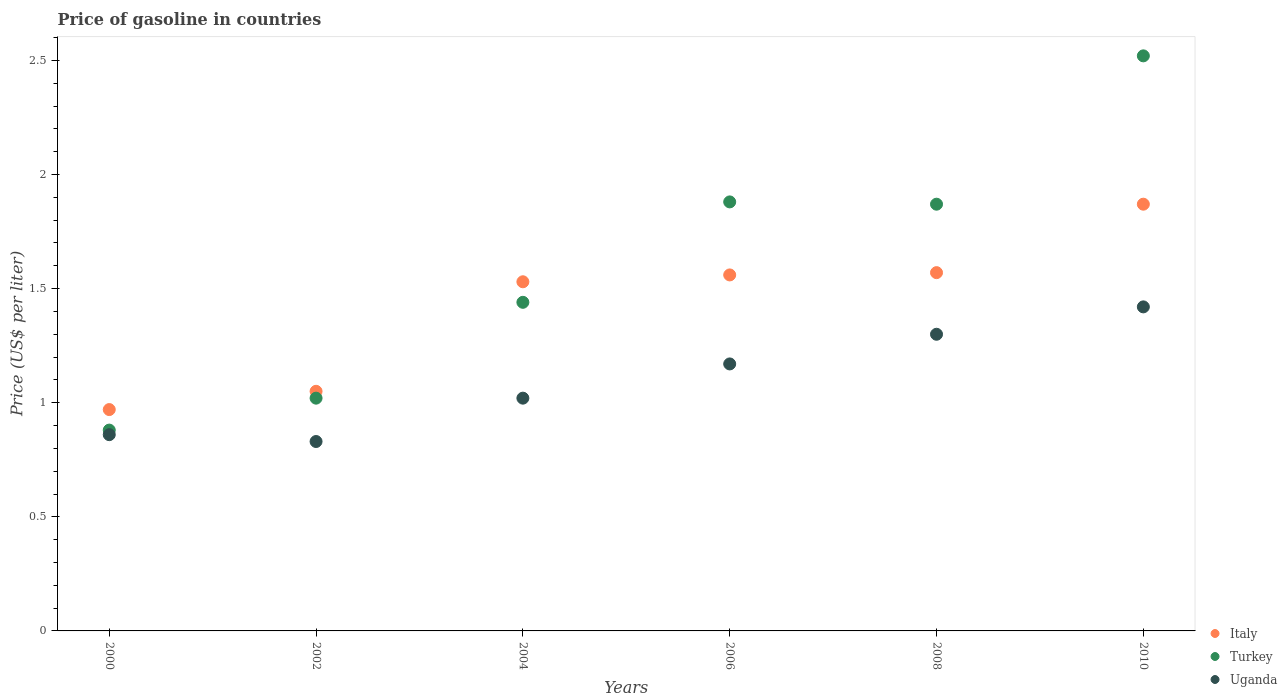How many different coloured dotlines are there?
Offer a terse response. 3. What is the price of gasoline in Turkey in 2006?
Your answer should be compact. 1.88. Across all years, what is the maximum price of gasoline in Italy?
Offer a terse response. 1.87. In which year was the price of gasoline in Italy maximum?
Your answer should be compact. 2010. In which year was the price of gasoline in Turkey minimum?
Your answer should be compact. 2000. What is the total price of gasoline in Turkey in the graph?
Offer a very short reply. 9.61. What is the difference between the price of gasoline in Italy in 2000 and that in 2006?
Provide a short and direct response. -0.59. What is the difference between the price of gasoline in Turkey in 2004 and the price of gasoline in Uganda in 2002?
Make the answer very short. 0.61. What is the average price of gasoline in Uganda per year?
Provide a succinct answer. 1.1. In the year 2002, what is the difference between the price of gasoline in Uganda and price of gasoline in Italy?
Give a very brief answer. -0.22. In how many years, is the price of gasoline in Uganda greater than 1 US$?
Offer a terse response. 4. What is the ratio of the price of gasoline in Uganda in 2006 to that in 2008?
Offer a terse response. 0.9. Is the price of gasoline in Uganda in 2004 less than that in 2010?
Your answer should be compact. Yes. What is the difference between the highest and the second highest price of gasoline in Italy?
Offer a very short reply. 0.3. What is the difference between the highest and the lowest price of gasoline in Italy?
Your response must be concise. 0.9. In how many years, is the price of gasoline in Uganda greater than the average price of gasoline in Uganda taken over all years?
Keep it short and to the point. 3. Is the price of gasoline in Turkey strictly less than the price of gasoline in Uganda over the years?
Provide a succinct answer. No. How many years are there in the graph?
Give a very brief answer. 6. What is the difference between two consecutive major ticks on the Y-axis?
Your answer should be compact. 0.5. Are the values on the major ticks of Y-axis written in scientific E-notation?
Keep it short and to the point. No. What is the title of the graph?
Provide a short and direct response. Price of gasoline in countries. What is the label or title of the Y-axis?
Your answer should be compact. Price (US$ per liter). What is the Price (US$ per liter) of Italy in 2000?
Offer a terse response. 0.97. What is the Price (US$ per liter) of Turkey in 2000?
Offer a very short reply. 0.88. What is the Price (US$ per liter) of Uganda in 2000?
Your answer should be very brief. 0.86. What is the Price (US$ per liter) of Uganda in 2002?
Give a very brief answer. 0.83. What is the Price (US$ per liter) in Italy in 2004?
Keep it short and to the point. 1.53. What is the Price (US$ per liter) of Turkey in 2004?
Your response must be concise. 1.44. What is the Price (US$ per liter) in Italy in 2006?
Offer a very short reply. 1.56. What is the Price (US$ per liter) in Turkey in 2006?
Provide a short and direct response. 1.88. What is the Price (US$ per liter) of Uganda in 2006?
Provide a short and direct response. 1.17. What is the Price (US$ per liter) in Italy in 2008?
Ensure brevity in your answer.  1.57. What is the Price (US$ per liter) of Turkey in 2008?
Provide a short and direct response. 1.87. What is the Price (US$ per liter) of Italy in 2010?
Provide a short and direct response. 1.87. What is the Price (US$ per liter) of Turkey in 2010?
Ensure brevity in your answer.  2.52. What is the Price (US$ per liter) of Uganda in 2010?
Give a very brief answer. 1.42. Across all years, what is the maximum Price (US$ per liter) in Italy?
Ensure brevity in your answer.  1.87. Across all years, what is the maximum Price (US$ per liter) in Turkey?
Your answer should be compact. 2.52. Across all years, what is the maximum Price (US$ per liter) in Uganda?
Your answer should be compact. 1.42. Across all years, what is the minimum Price (US$ per liter) in Italy?
Your answer should be compact. 0.97. Across all years, what is the minimum Price (US$ per liter) in Turkey?
Provide a short and direct response. 0.88. Across all years, what is the minimum Price (US$ per liter) in Uganda?
Provide a short and direct response. 0.83. What is the total Price (US$ per liter) in Italy in the graph?
Make the answer very short. 8.55. What is the total Price (US$ per liter) in Turkey in the graph?
Your response must be concise. 9.61. What is the total Price (US$ per liter) in Uganda in the graph?
Keep it short and to the point. 6.6. What is the difference between the Price (US$ per liter) in Italy in 2000 and that in 2002?
Your response must be concise. -0.08. What is the difference between the Price (US$ per liter) of Turkey in 2000 and that in 2002?
Make the answer very short. -0.14. What is the difference between the Price (US$ per liter) of Italy in 2000 and that in 2004?
Your response must be concise. -0.56. What is the difference between the Price (US$ per liter) of Turkey in 2000 and that in 2004?
Make the answer very short. -0.56. What is the difference between the Price (US$ per liter) of Uganda in 2000 and that in 2004?
Give a very brief answer. -0.16. What is the difference between the Price (US$ per liter) in Italy in 2000 and that in 2006?
Make the answer very short. -0.59. What is the difference between the Price (US$ per liter) of Uganda in 2000 and that in 2006?
Ensure brevity in your answer.  -0.31. What is the difference between the Price (US$ per liter) of Italy in 2000 and that in 2008?
Your response must be concise. -0.6. What is the difference between the Price (US$ per liter) of Turkey in 2000 and that in 2008?
Give a very brief answer. -0.99. What is the difference between the Price (US$ per liter) in Uganda in 2000 and that in 2008?
Provide a short and direct response. -0.44. What is the difference between the Price (US$ per liter) in Turkey in 2000 and that in 2010?
Your response must be concise. -1.64. What is the difference between the Price (US$ per liter) in Uganda in 2000 and that in 2010?
Offer a very short reply. -0.56. What is the difference between the Price (US$ per liter) of Italy in 2002 and that in 2004?
Your response must be concise. -0.48. What is the difference between the Price (US$ per liter) in Turkey in 2002 and that in 2004?
Offer a very short reply. -0.42. What is the difference between the Price (US$ per liter) in Uganda in 2002 and that in 2004?
Offer a very short reply. -0.19. What is the difference between the Price (US$ per liter) in Italy in 2002 and that in 2006?
Offer a very short reply. -0.51. What is the difference between the Price (US$ per liter) in Turkey in 2002 and that in 2006?
Give a very brief answer. -0.86. What is the difference between the Price (US$ per liter) in Uganda in 2002 and that in 2006?
Offer a very short reply. -0.34. What is the difference between the Price (US$ per liter) in Italy in 2002 and that in 2008?
Offer a very short reply. -0.52. What is the difference between the Price (US$ per liter) of Turkey in 2002 and that in 2008?
Your response must be concise. -0.85. What is the difference between the Price (US$ per liter) in Uganda in 2002 and that in 2008?
Provide a succinct answer. -0.47. What is the difference between the Price (US$ per liter) in Italy in 2002 and that in 2010?
Your answer should be compact. -0.82. What is the difference between the Price (US$ per liter) of Uganda in 2002 and that in 2010?
Your answer should be compact. -0.59. What is the difference between the Price (US$ per liter) of Italy in 2004 and that in 2006?
Your response must be concise. -0.03. What is the difference between the Price (US$ per liter) of Turkey in 2004 and that in 2006?
Offer a very short reply. -0.44. What is the difference between the Price (US$ per liter) in Italy in 2004 and that in 2008?
Provide a short and direct response. -0.04. What is the difference between the Price (US$ per liter) of Turkey in 2004 and that in 2008?
Ensure brevity in your answer.  -0.43. What is the difference between the Price (US$ per liter) of Uganda in 2004 and that in 2008?
Provide a short and direct response. -0.28. What is the difference between the Price (US$ per liter) in Italy in 2004 and that in 2010?
Provide a short and direct response. -0.34. What is the difference between the Price (US$ per liter) of Turkey in 2004 and that in 2010?
Offer a very short reply. -1.08. What is the difference between the Price (US$ per liter) in Italy in 2006 and that in 2008?
Ensure brevity in your answer.  -0.01. What is the difference between the Price (US$ per liter) of Turkey in 2006 and that in 2008?
Provide a short and direct response. 0.01. What is the difference between the Price (US$ per liter) of Uganda in 2006 and that in 2008?
Your answer should be very brief. -0.13. What is the difference between the Price (US$ per liter) in Italy in 2006 and that in 2010?
Keep it short and to the point. -0.31. What is the difference between the Price (US$ per liter) of Turkey in 2006 and that in 2010?
Your answer should be compact. -0.64. What is the difference between the Price (US$ per liter) of Italy in 2008 and that in 2010?
Your response must be concise. -0.3. What is the difference between the Price (US$ per liter) of Turkey in 2008 and that in 2010?
Keep it short and to the point. -0.65. What is the difference between the Price (US$ per liter) in Uganda in 2008 and that in 2010?
Offer a terse response. -0.12. What is the difference between the Price (US$ per liter) in Italy in 2000 and the Price (US$ per liter) in Uganda in 2002?
Give a very brief answer. 0.14. What is the difference between the Price (US$ per liter) in Italy in 2000 and the Price (US$ per liter) in Turkey in 2004?
Give a very brief answer. -0.47. What is the difference between the Price (US$ per liter) in Italy in 2000 and the Price (US$ per liter) in Uganda in 2004?
Offer a terse response. -0.05. What is the difference between the Price (US$ per liter) of Turkey in 2000 and the Price (US$ per liter) of Uganda in 2004?
Give a very brief answer. -0.14. What is the difference between the Price (US$ per liter) in Italy in 2000 and the Price (US$ per liter) in Turkey in 2006?
Offer a very short reply. -0.91. What is the difference between the Price (US$ per liter) in Turkey in 2000 and the Price (US$ per liter) in Uganda in 2006?
Provide a short and direct response. -0.29. What is the difference between the Price (US$ per liter) of Italy in 2000 and the Price (US$ per liter) of Uganda in 2008?
Provide a succinct answer. -0.33. What is the difference between the Price (US$ per liter) in Turkey in 2000 and the Price (US$ per liter) in Uganda in 2008?
Offer a terse response. -0.42. What is the difference between the Price (US$ per liter) in Italy in 2000 and the Price (US$ per liter) in Turkey in 2010?
Offer a very short reply. -1.55. What is the difference between the Price (US$ per liter) in Italy in 2000 and the Price (US$ per liter) in Uganda in 2010?
Provide a short and direct response. -0.45. What is the difference between the Price (US$ per liter) in Turkey in 2000 and the Price (US$ per liter) in Uganda in 2010?
Your answer should be compact. -0.54. What is the difference between the Price (US$ per liter) in Italy in 2002 and the Price (US$ per liter) in Turkey in 2004?
Make the answer very short. -0.39. What is the difference between the Price (US$ per liter) of Italy in 2002 and the Price (US$ per liter) of Uganda in 2004?
Your answer should be very brief. 0.03. What is the difference between the Price (US$ per liter) in Turkey in 2002 and the Price (US$ per liter) in Uganda in 2004?
Your answer should be compact. 0. What is the difference between the Price (US$ per liter) of Italy in 2002 and the Price (US$ per liter) of Turkey in 2006?
Offer a terse response. -0.83. What is the difference between the Price (US$ per liter) of Italy in 2002 and the Price (US$ per liter) of Uganda in 2006?
Offer a terse response. -0.12. What is the difference between the Price (US$ per liter) of Italy in 2002 and the Price (US$ per liter) of Turkey in 2008?
Offer a very short reply. -0.82. What is the difference between the Price (US$ per liter) in Turkey in 2002 and the Price (US$ per liter) in Uganda in 2008?
Keep it short and to the point. -0.28. What is the difference between the Price (US$ per liter) in Italy in 2002 and the Price (US$ per liter) in Turkey in 2010?
Keep it short and to the point. -1.47. What is the difference between the Price (US$ per liter) in Italy in 2002 and the Price (US$ per liter) in Uganda in 2010?
Offer a terse response. -0.37. What is the difference between the Price (US$ per liter) in Italy in 2004 and the Price (US$ per liter) in Turkey in 2006?
Provide a succinct answer. -0.35. What is the difference between the Price (US$ per liter) in Italy in 2004 and the Price (US$ per liter) in Uganda in 2006?
Give a very brief answer. 0.36. What is the difference between the Price (US$ per liter) of Turkey in 2004 and the Price (US$ per liter) of Uganda in 2006?
Your answer should be compact. 0.27. What is the difference between the Price (US$ per liter) of Italy in 2004 and the Price (US$ per liter) of Turkey in 2008?
Your answer should be compact. -0.34. What is the difference between the Price (US$ per liter) of Italy in 2004 and the Price (US$ per liter) of Uganda in 2008?
Offer a very short reply. 0.23. What is the difference between the Price (US$ per liter) in Turkey in 2004 and the Price (US$ per liter) in Uganda in 2008?
Provide a succinct answer. 0.14. What is the difference between the Price (US$ per liter) of Italy in 2004 and the Price (US$ per liter) of Turkey in 2010?
Your answer should be very brief. -0.99. What is the difference between the Price (US$ per liter) of Italy in 2004 and the Price (US$ per liter) of Uganda in 2010?
Make the answer very short. 0.11. What is the difference between the Price (US$ per liter) of Turkey in 2004 and the Price (US$ per liter) of Uganda in 2010?
Ensure brevity in your answer.  0.02. What is the difference between the Price (US$ per liter) of Italy in 2006 and the Price (US$ per liter) of Turkey in 2008?
Your answer should be compact. -0.31. What is the difference between the Price (US$ per liter) in Italy in 2006 and the Price (US$ per liter) in Uganda in 2008?
Provide a succinct answer. 0.26. What is the difference between the Price (US$ per liter) in Turkey in 2006 and the Price (US$ per liter) in Uganda in 2008?
Provide a short and direct response. 0.58. What is the difference between the Price (US$ per liter) in Italy in 2006 and the Price (US$ per liter) in Turkey in 2010?
Your answer should be compact. -0.96. What is the difference between the Price (US$ per liter) of Italy in 2006 and the Price (US$ per liter) of Uganda in 2010?
Ensure brevity in your answer.  0.14. What is the difference between the Price (US$ per liter) of Turkey in 2006 and the Price (US$ per liter) of Uganda in 2010?
Your response must be concise. 0.46. What is the difference between the Price (US$ per liter) in Italy in 2008 and the Price (US$ per liter) in Turkey in 2010?
Provide a succinct answer. -0.95. What is the difference between the Price (US$ per liter) in Turkey in 2008 and the Price (US$ per liter) in Uganda in 2010?
Provide a succinct answer. 0.45. What is the average Price (US$ per liter) in Italy per year?
Ensure brevity in your answer.  1.43. What is the average Price (US$ per liter) in Turkey per year?
Give a very brief answer. 1.6. What is the average Price (US$ per liter) of Uganda per year?
Keep it short and to the point. 1.1. In the year 2000, what is the difference between the Price (US$ per liter) in Italy and Price (US$ per liter) in Turkey?
Ensure brevity in your answer.  0.09. In the year 2000, what is the difference between the Price (US$ per liter) of Italy and Price (US$ per liter) of Uganda?
Offer a very short reply. 0.11. In the year 2000, what is the difference between the Price (US$ per liter) in Turkey and Price (US$ per liter) in Uganda?
Your answer should be compact. 0.02. In the year 2002, what is the difference between the Price (US$ per liter) of Italy and Price (US$ per liter) of Turkey?
Offer a terse response. 0.03. In the year 2002, what is the difference between the Price (US$ per liter) in Italy and Price (US$ per liter) in Uganda?
Your response must be concise. 0.22. In the year 2002, what is the difference between the Price (US$ per liter) in Turkey and Price (US$ per liter) in Uganda?
Provide a succinct answer. 0.19. In the year 2004, what is the difference between the Price (US$ per liter) in Italy and Price (US$ per liter) in Turkey?
Provide a short and direct response. 0.09. In the year 2004, what is the difference between the Price (US$ per liter) in Italy and Price (US$ per liter) in Uganda?
Your answer should be very brief. 0.51. In the year 2004, what is the difference between the Price (US$ per liter) of Turkey and Price (US$ per liter) of Uganda?
Keep it short and to the point. 0.42. In the year 2006, what is the difference between the Price (US$ per liter) in Italy and Price (US$ per liter) in Turkey?
Give a very brief answer. -0.32. In the year 2006, what is the difference between the Price (US$ per liter) in Italy and Price (US$ per liter) in Uganda?
Provide a succinct answer. 0.39. In the year 2006, what is the difference between the Price (US$ per liter) of Turkey and Price (US$ per liter) of Uganda?
Provide a succinct answer. 0.71. In the year 2008, what is the difference between the Price (US$ per liter) of Italy and Price (US$ per liter) of Uganda?
Offer a terse response. 0.27. In the year 2008, what is the difference between the Price (US$ per liter) in Turkey and Price (US$ per liter) in Uganda?
Your answer should be very brief. 0.57. In the year 2010, what is the difference between the Price (US$ per liter) in Italy and Price (US$ per liter) in Turkey?
Offer a terse response. -0.65. In the year 2010, what is the difference between the Price (US$ per liter) of Italy and Price (US$ per liter) of Uganda?
Give a very brief answer. 0.45. In the year 2010, what is the difference between the Price (US$ per liter) of Turkey and Price (US$ per liter) of Uganda?
Your answer should be very brief. 1.1. What is the ratio of the Price (US$ per liter) of Italy in 2000 to that in 2002?
Give a very brief answer. 0.92. What is the ratio of the Price (US$ per liter) in Turkey in 2000 to that in 2002?
Your answer should be very brief. 0.86. What is the ratio of the Price (US$ per liter) in Uganda in 2000 to that in 2002?
Provide a succinct answer. 1.04. What is the ratio of the Price (US$ per liter) of Italy in 2000 to that in 2004?
Give a very brief answer. 0.63. What is the ratio of the Price (US$ per liter) in Turkey in 2000 to that in 2004?
Offer a terse response. 0.61. What is the ratio of the Price (US$ per liter) of Uganda in 2000 to that in 2004?
Keep it short and to the point. 0.84. What is the ratio of the Price (US$ per liter) of Italy in 2000 to that in 2006?
Make the answer very short. 0.62. What is the ratio of the Price (US$ per liter) in Turkey in 2000 to that in 2006?
Your answer should be very brief. 0.47. What is the ratio of the Price (US$ per liter) in Uganda in 2000 to that in 2006?
Provide a succinct answer. 0.73. What is the ratio of the Price (US$ per liter) of Italy in 2000 to that in 2008?
Make the answer very short. 0.62. What is the ratio of the Price (US$ per liter) in Turkey in 2000 to that in 2008?
Give a very brief answer. 0.47. What is the ratio of the Price (US$ per liter) in Uganda in 2000 to that in 2008?
Give a very brief answer. 0.66. What is the ratio of the Price (US$ per liter) in Italy in 2000 to that in 2010?
Your response must be concise. 0.52. What is the ratio of the Price (US$ per liter) of Turkey in 2000 to that in 2010?
Offer a very short reply. 0.35. What is the ratio of the Price (US$ per liter) in Uganda in 2000 to that in 2010?
Provide a short and direct response. 0.61. What is the ratio of the Price (US$ per liter) of Italy in 2002 to that in 2004?
Make the answer very short. 0.69. What is the ratio of the Price (US$ per liter) of Turkey in 2002 to that in 2004?
Your answer should be compact. 0.71. What is the ratio of the Price (US$ per liter) of Uganda in 2002 to that in 2004?
Provide a short and direct response. 0.81. What is the ratio of the Price (US$ per liter) in Italy in 2002 to that in 2006?
Make the answer very short. 0.67. What is the ratio of the Price (US$ per liter) in Turkey in 2002 to that in 2006?
Offer a terse response. 0.54. What is the ratio of the Price (US$ per liter) of Uganda in 2002 to that in 2006?
Offer a very short reply. 0.71. What is the ratio of the Price (US$ per liter) of Italy in 2002 to that in 2008?
Ensure brevity in your answer.  0.67. What is the ratio of the Price (US$ per liter) of Turkey in 2002 to that in 2008?
Ensure brevity in your answer.  0.55. What is the ratio of the Price (US$ per liter) in Uganda in 2002 to that in 2008?
Make the answer very short. 0.64. What is the ratio of the Price (US$ per liter) of Italy in 2002 to that in 2010?
Provide a short and direct response. 0.56. What is the ratio of the Price (US$ per liter) in Turkey in 2002 to that in 2010?
Make the answer very short. 0.4. What is the ratio of the Price (US$ per liter) in Uganda in 2002 to that in 2010?
Keep it short and to the point. 0.58. What is the ratio of the Price (US$ per liter) in Italy in 2004 to that in 2006?
Your answer should be compact. 0.98. What is the ratio of the Price (US$ per liter) in Turkey in 2004 to that in 2006?
Provide a short and direct response. 0.77. What is the ratio of the Price (US$ per liter) in Uganda in 2004 to that in 2006?
Your response must be concise. 0.87. What is the ratio of the Price (US$ per liter) of Italy in 2004 to that in 2008?
Provide a succinct answer. 0.97. What is the ratio of the Price (US$ per liter) in Turkey in 2004 to that in 2008?
Provide a short and direct response. 0.77. What is the ratio of the Price (US$ per liter) of Uganda in 2004 to that in 2008?
Offer a terse response. 0.78. What is the ratio of the Price (US$ per liter) of Italy in 2004 to that in 2010?
Keep it short and to the point. 0.82. What is the ratio of the Price (US$ per liter) in Turkey in 2004 to that in 2010?
Provide a succinct answer. 0.57. What is the ratio of the Price (US$ per liter) in Uganda in 2004 to that in 2010?
Give a very brief answer. 0.72. What is the ratio of the Price (US$ per liter) in Italy in 2006 to that in 2008?
Your answer should be compact. 0.99. What is the ratio of the Price (US$ per liter) of Uganda in 2006 to that in 2008?
Make the answer very short. 0.9. What is the ratio of the Price (US$ per liter) of Italy in 2006 to that in 2010?
Your answer should be compact. 0.83. What is the ratio of the Price (US$ per liter) of Turkey in 2006 to that in 2010?
Your answer should be compact. 0.75. What is the ratio of the Price (US$ per liter) of Uganda in 2006 to that in 2010?
Your answer should be very brief. 0.82. What is the ratio of the Price (US$ per liter) of Italy in 2008 to that in 2010?
Provide a succinct answer. 0.84. What is the ratio of the Price (US$ per liter) in Turkey in 2008 to that in 2010?
Ensure brevity in your answer.  0.74. What is the ratio of the Price (US$ per liter) in Uganda in 2008 to that in 2010?
Your answer should be very brief. 0.92. What is the difference between the highest and the second highest Price (US$ per liter) in Turkey?
Make the answer very short. 0.64. What is the difference between the highest and the second highest Price (US$ per liter) of Uganda?
Offer a terse response. 0.12. What is the difference between the highest and the lowest Price (US$ per liter) in Turkey?
Ensure brevity in your answer.  1.64. What is the difference between the highest and the lowest Price (US$ per liter) in Uganda?
Offer a terse response. 0.59. 